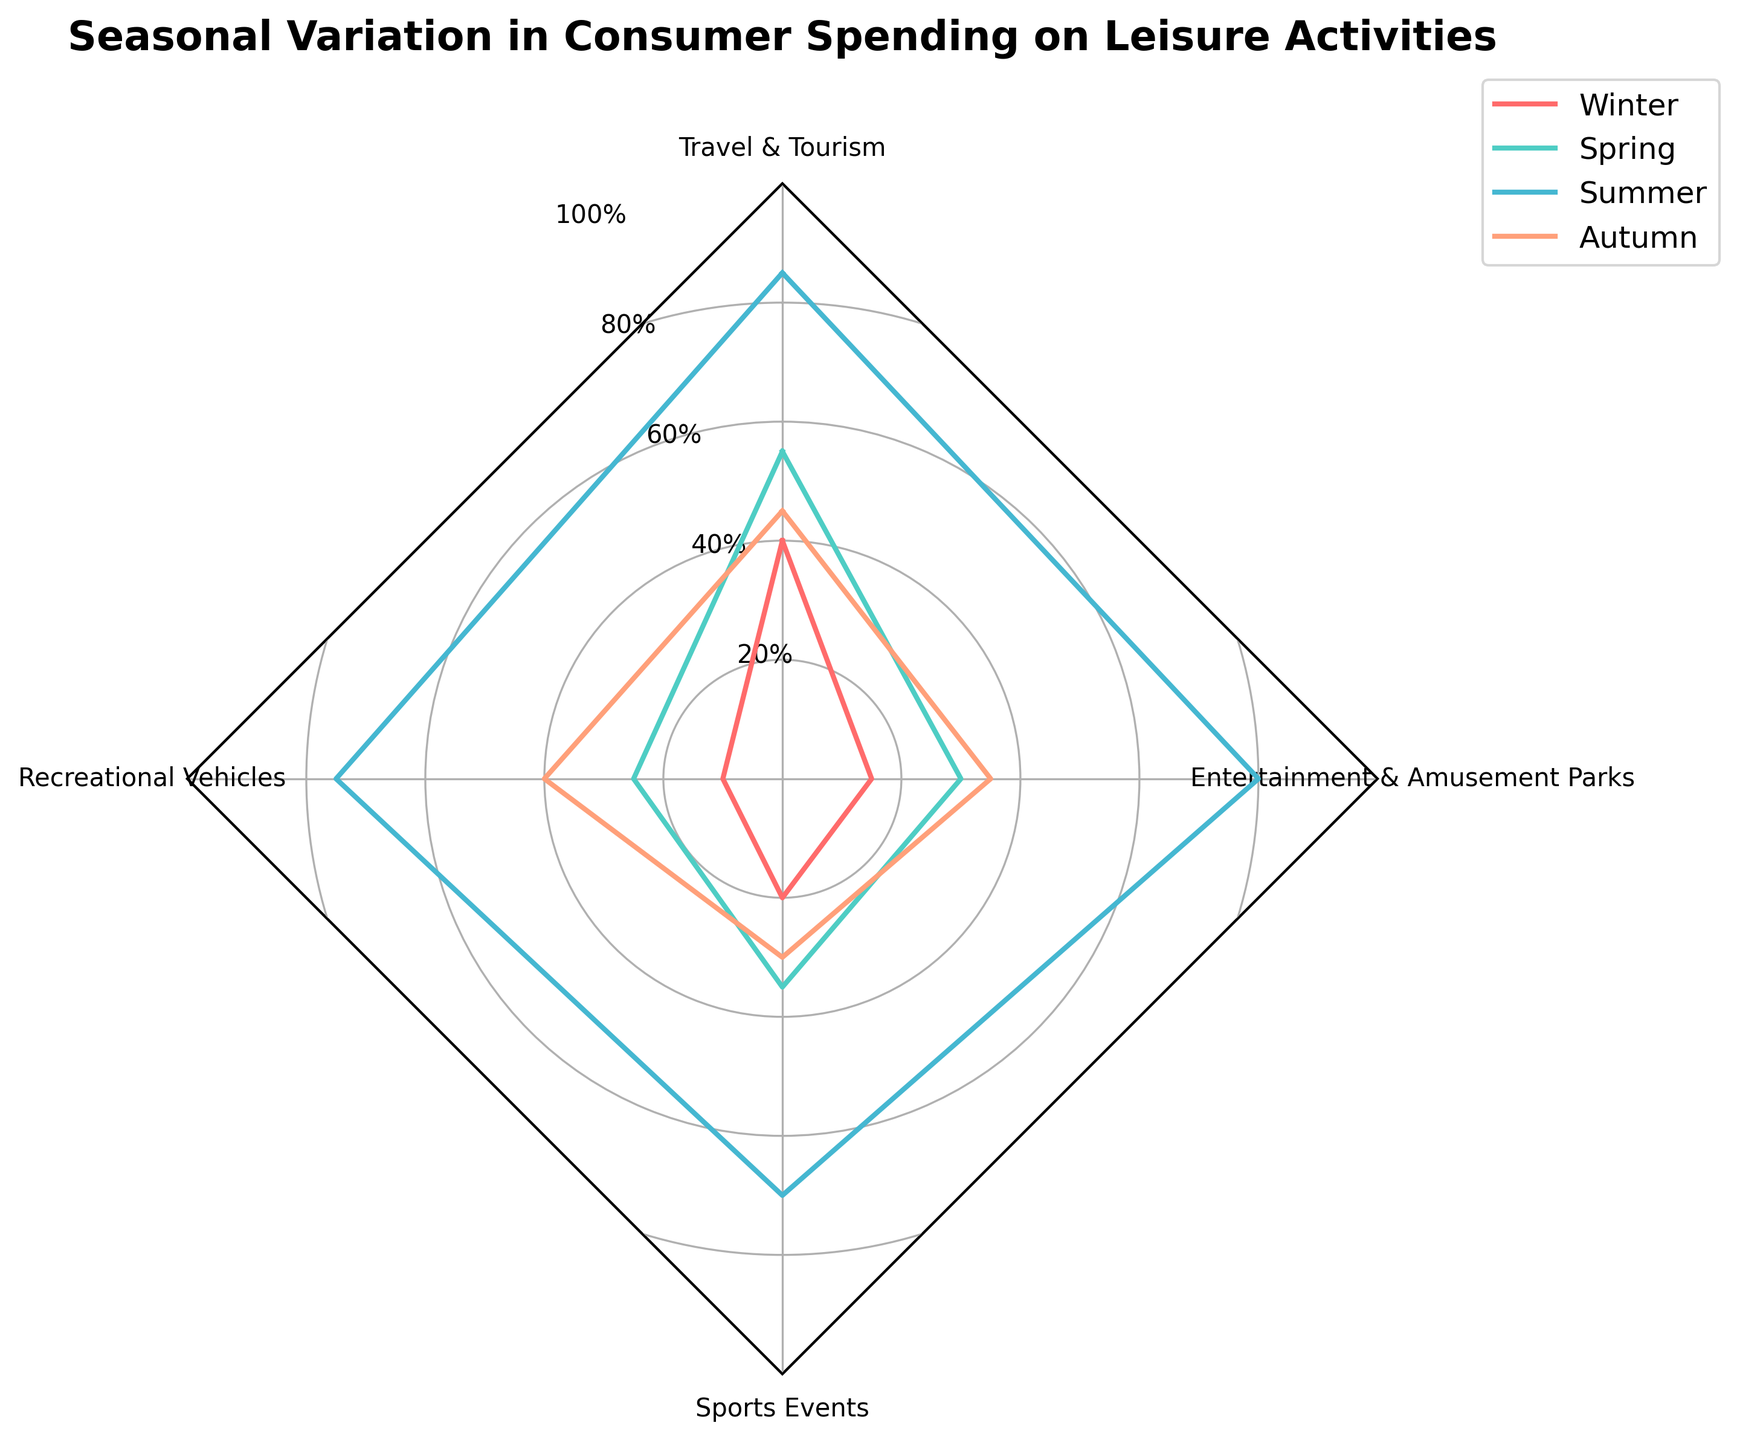What is the title of the radar chart? The title is typically located at the top of the chart in the largest font size. In this case, it reads "Seasonal Variation in Consumer Spending on Leisure Activities".
Answer: Seasonal Variation in Consumer Spending on Leisure Activities What are the four categories represented on the radar chart? The category labels are positioned on the edges of the radar chart, correlating to the data points. They are "Travel & Tourism", "Recreational Vehicles", "Sports Events", and "Entertainment & Amusement Parks".
Answer: Travel & Tourism, Recreational Vehicles, Sports Events, Entertainment & Amusement Parks Which season shows the highest consumer spending in "Recreational Vehicles"? To find this, observe the lines and filled areas corresponding to each season. The highest point in the "Recreational Vehicles" category on the radar chart is 75, which belongs to Summer.
Answer: Summer What is the average consumer spending in the "Winter" season across all categories? To calculate the average, sum the values for "Winter" season across all categories (40 + 10 + 20 + 15 = 85) and divide by the number of categories (4). Therefore, the average is 85/4 = 21.25.
Answer: 21.25 Which leisure activity has the lowest consumer spending in "Spring"? By examining the points for each category in the Spring season, we find that "Recreational Vehicles" has the lowest value of 25.
Answer: Recreational Vehicles Compare and state the difference in consumer spending for "Sports Events" between "Summer" and "Autumn". Find the values for "Sports Events" in Summer (70) and Autumn (30). The difference is 70 - 30 = 40.
Answer: 40 Which season has the most even distribution of consumer spending across all four categories? To determine this, observe the variation in points for each season. Spring season varies from 25 to 55, which is relatively even compared to other seasons.
Answer: Spring In terms of consumer spending, which leisure activity has the most significant increase from "Winter" to "Summer"? Calculate the increase for each category from Winter to Summer. "Recreational Vehicles" increases from 10 to 75, which is the largest increase of 65.
Answer: Recreational Vehicles How does the spending on "Entertainment & Amusement Parks" in "Autumn" compare to "Winter"? Locate the values for "Entertainment & Amusement Parks" for both autumn (35) and winter (15). The spending in Autumn is higher by 35 - 15 = 20.
Answer: Autumn is higher by 20 What are the colors used to represent the seasons in the radar chart? The colors for each season are identifiable by their respective filled areas and lines. They are red for Winter, teal for Spring, blue for Summer, and salmon for Autumn.
Answer: Red for Winter, teal for Spring, blue for Summer, and salmon for Autumn 